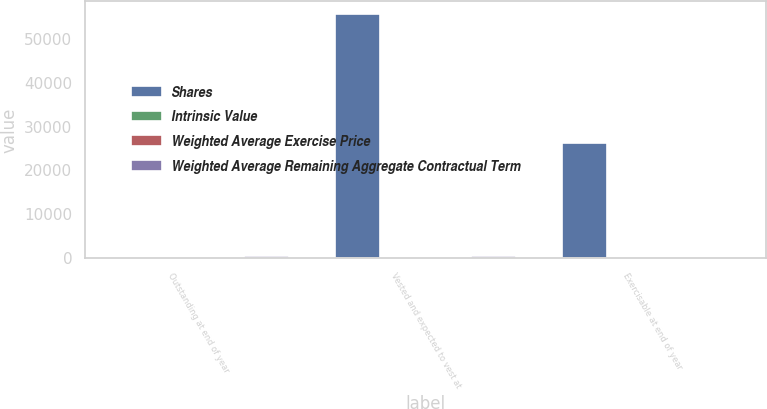Convert chart to OTSL. <chart><loc_0><loc_0><loc_500><loc_500><stacked_bar_chart><ecel><fcel>Outstanding at end of year<fcel>Vested and expected to vest at<fcel>Exercisable at end of year<nl><fcel>Shares<fcel>15<fcel>55716<fcel>26204<nl><fcel>Intrinsic Value<fcel>15<fcel>15<fcel>13<nl><fcel>Weighted Average Exercise Price<fcel>5.4<fcel>5.3<fcel>3.8<nl><fcel>Weighted Average Remaining Aggregate Contractual Term<fcel>437<fcel>425<fcel>241<nl></chart> 